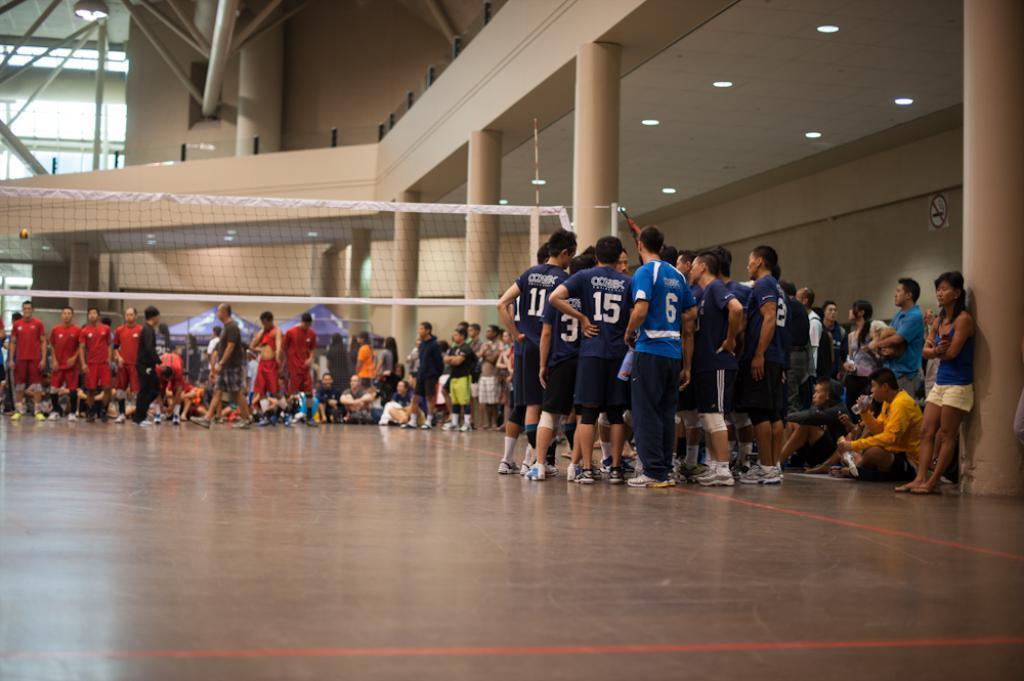Could you give a brief overview of what you see in this image? There are groups of people standing and sitting. This looks like a volleyball net. These are the pillars. I can see the ceiling lights. I think this is the iron poles. I can see the canopy tents. 